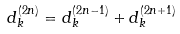Convert formula to latex. <formula><loc_0><loc_0><loc_500><loc_500>d _ { k } ^ { ( 2 n ) } = d _ { k } ^ { ( 2 n - 1 ) } + d _ { k } ^ { ( 2 n + 1 ) }</formula> 